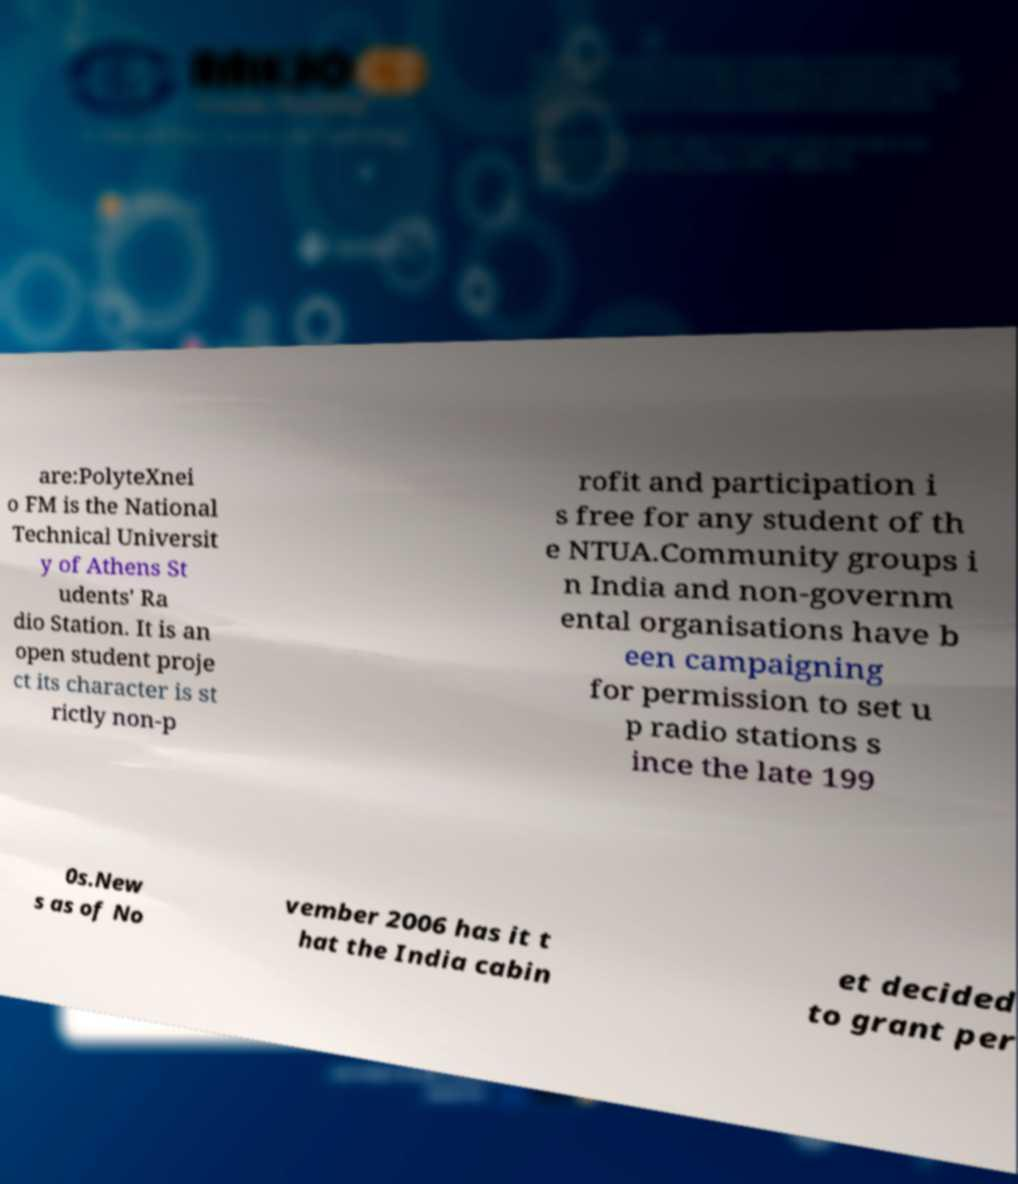Could you assist in decoding the text presented in this image and type it out clearly? are:PolyteXnei o FM is the National Technical Universit y of Athens St udents' Ra dio Station. It is an open student proje ct its character is st rictly non-p rofit and participation i s free for any student of th e NTUA.Community groups i n India and non-governm ental organisations have b een campaigning for permission to set u p radio stations s ince the late 199 0s.New s as of No vember 2006 has it t hat the India cabin et decided to grant per 